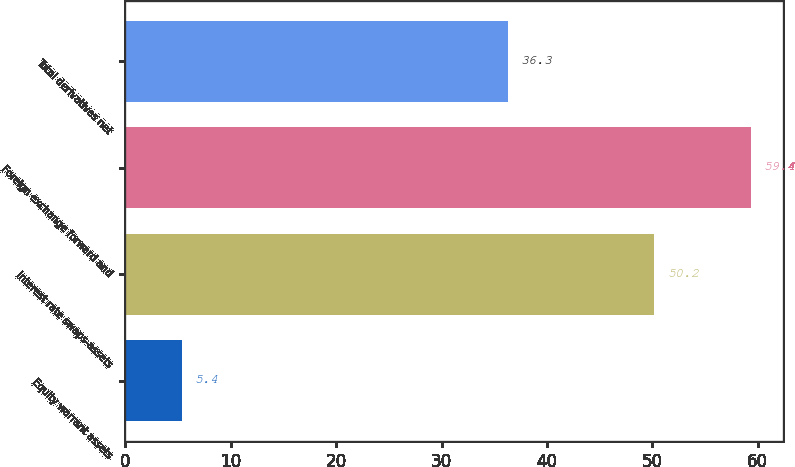Convert chart. <chart><loc_0><loc_0><loc_500><loc_500><bar_chart><fcel>Equity warrant assets<fcel>Interest rate swaps-assets<fcel>Foreign exchange forward and<fcel>Total derivatives net<nl><fcel>5.4<fcel>50.2<fcel>59.4<fcel>36.3<nl></chart> 